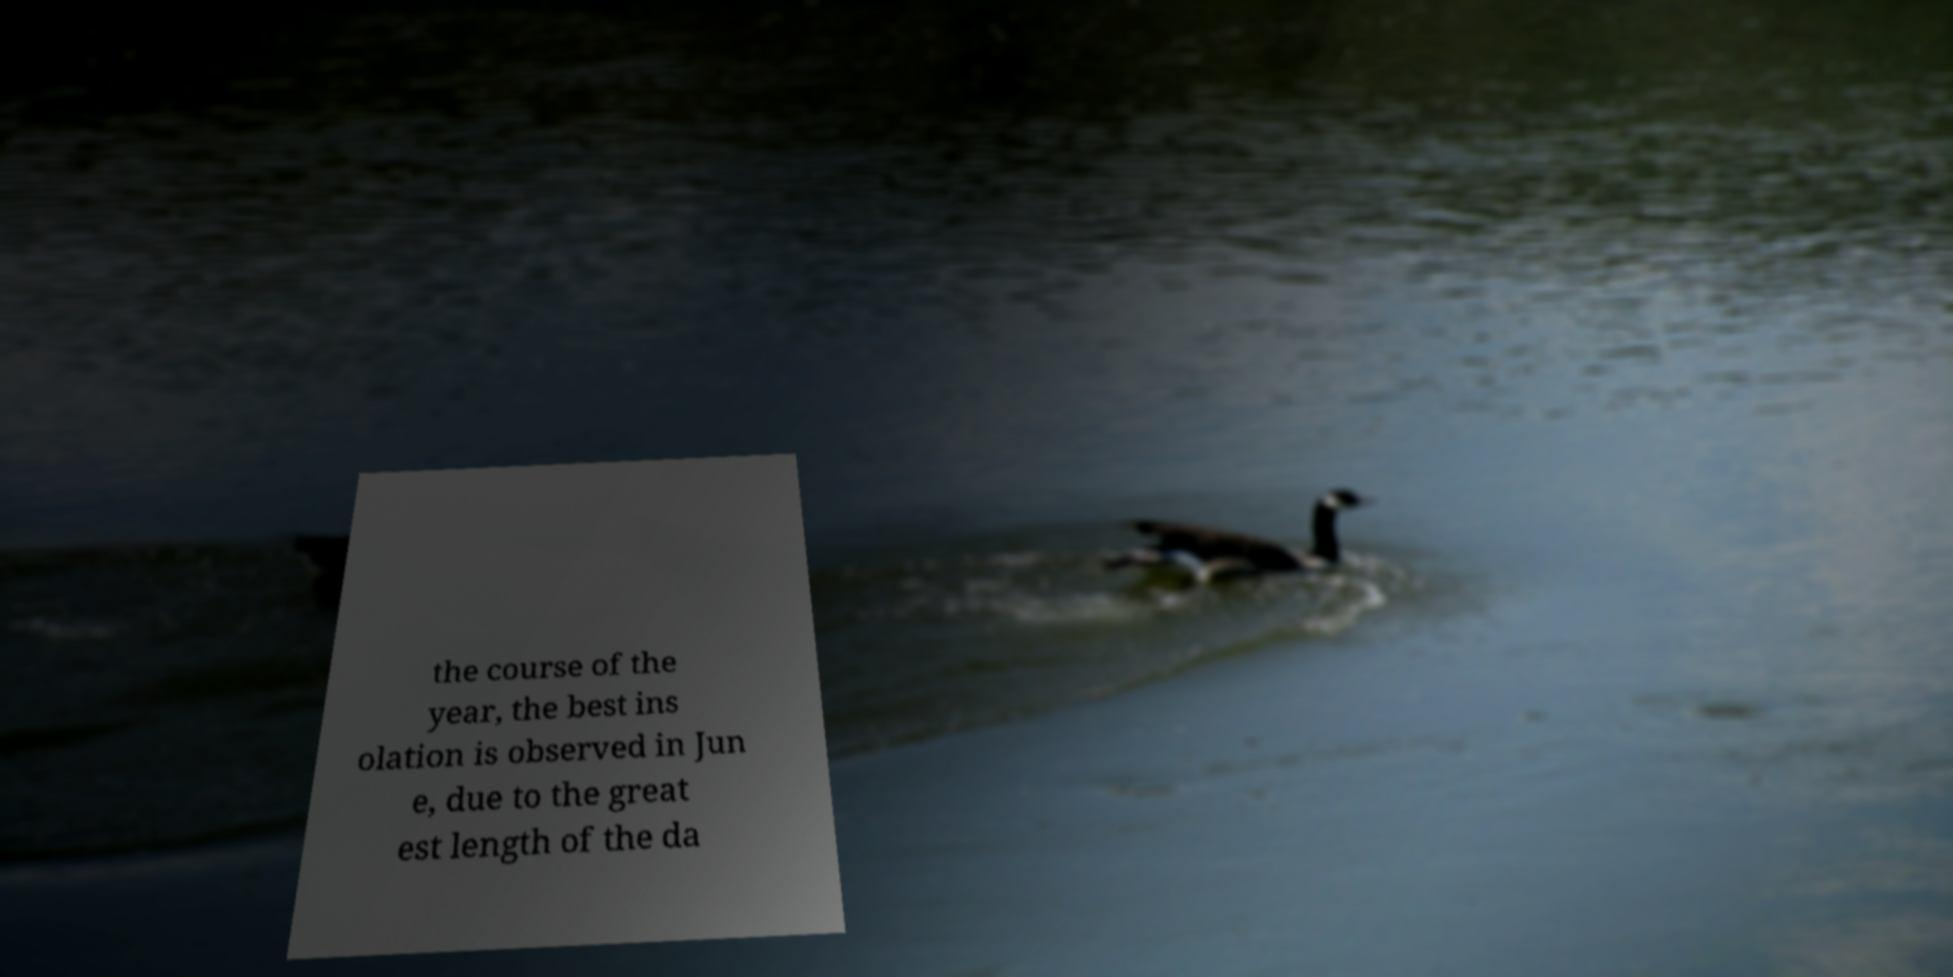Can you accurately transcribe the text from the provided image for me? the course of the year, the best ins olation is observed in Jun e, due to the great est length of the da 